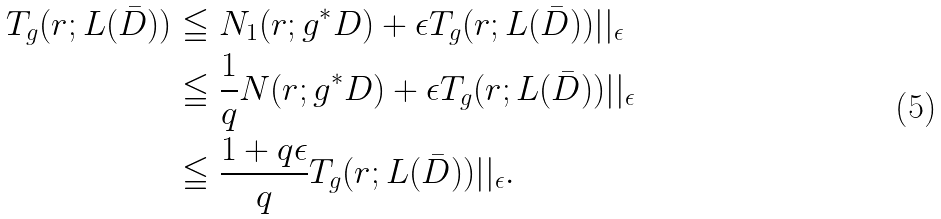<formula> <loc_0><loc_0><loc_500><loc_500>T _ { g } ( r ; L ( \bar { D } ) ) & \leqq N _ { 1 } ( r ; g ^ { * } D ) + \epsilon T _ { g } ( r ; L ( \bar { D } ) ) | | _ { \epsilon } \\ & \leqq \frac { 1 } { q } N ( r ; g ^ { * } D ) + \epsilon T _ { g } ( r ; L ( \bar { D } ) ) | | _ { \epsilon } \\ & \leqq \frac { 1 + q \epsilon } { q } T _ { g } ( r ; L ( \bar { D } ) ) | | _ { \epsilon } .</formula> 